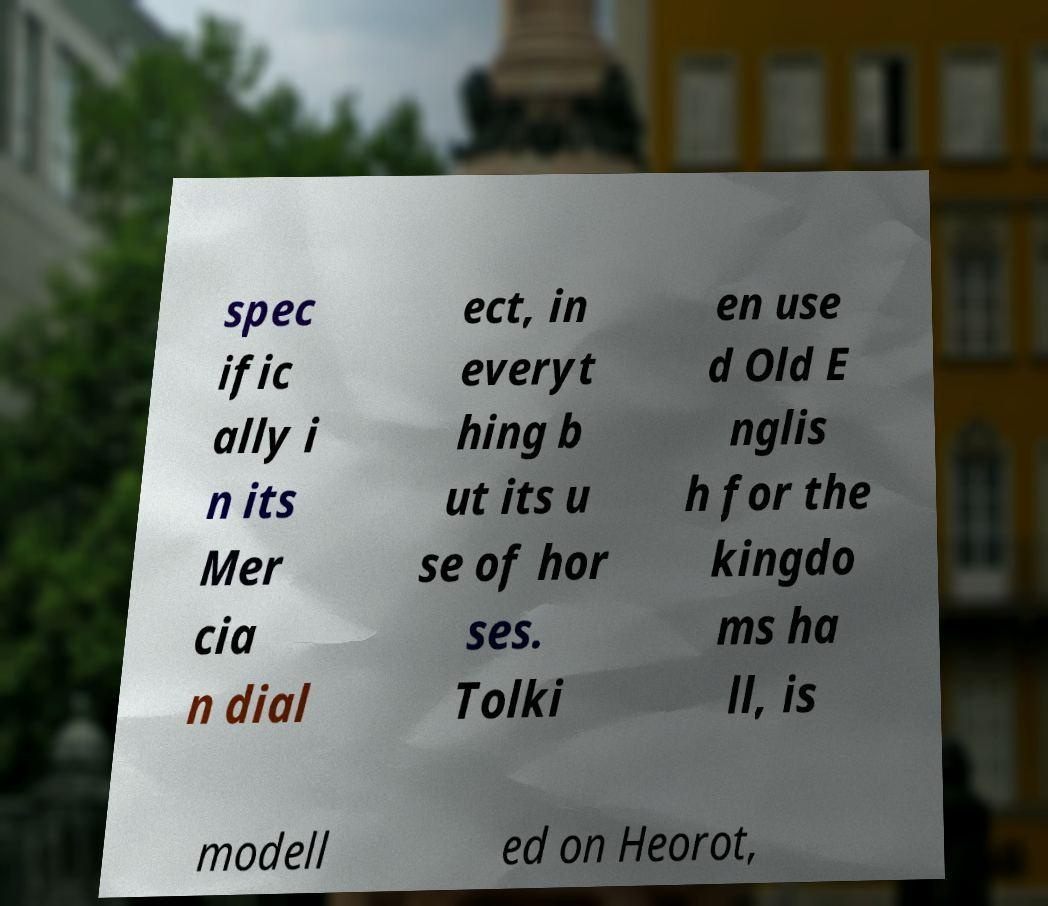There's text embedded in this image that I need extracted. Can you transcribe it verbatim? spec ific ally i n its Mer cia n dial ect, in everyt hing b ut its u se of hor ses. Tolki en use d Old E nglis h for the kingdo ms ha ll, is modell ed on Heorot, 